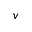Convert formula to latex. <formula><loc_0><loc_0><loc_500><loc_500>v</formula> 